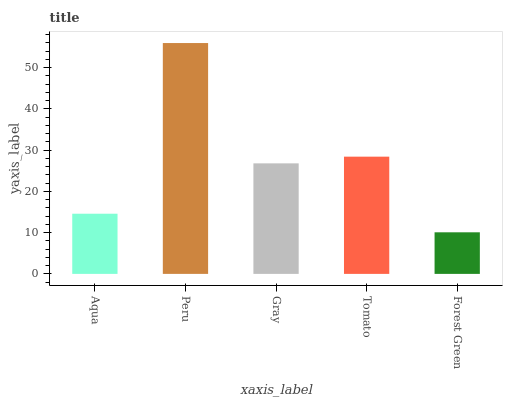Is Forest Green the minimum?
Answer yes or no. Yes. Is Peru the maximum?
Answer yes or no. Yes. Is Gray the minimum?
Answer yes or no. No. Is Gray the maximum?
Answer yes or no. No. Is Peru greater than Gray?
Answer yes or no. Yes. Is Gray less than Peru?
Answer yes or no. Yes. Is Gray greater than Peru?
Answer yes or no. No. Is Peru less than Gray?
Answer yes or no. No. Is Gray the high median?
Answer yes or no. Yes. Is Gray the low median?
Answer yes or no. Yes. Is Aqua the high median?
Answer yes or no. No. Is Tomato the low median?
Answer yes or no. No. 